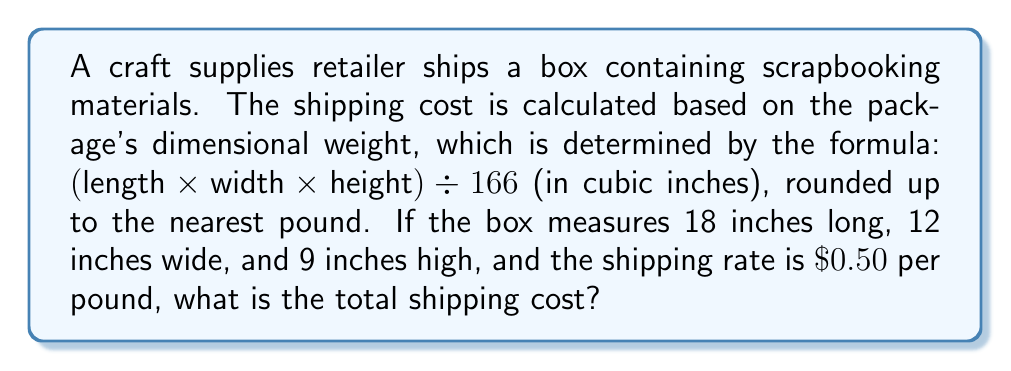Teach me how to tackle this problem. 1. Calculate the volume of the box:
   $\text{Volume} = \text{length} \times \text{width} \times \text{height}$
   $\text{Volume} = 18 \times 12 \times 9 = 1,944 \text{ cubic inches}$

2. Calculate the dimensional weight:
   $\text{Dimensional Weight} = \frac{\text{Volume}}{166}$
   $\text{Dimensional Weight} = \frac{1,944}{166} \approx 11.71 \text{ pounds}$

3. Round up the dimensional weight to the nearest pound:
   $\text{Rounded Weight} = 12 \text{ pounds}$

4. Calculate the shipping cost:
   $\text{Shipping Cost} = \text{Rounded Weight} \times \text{Rate per pound}$
   $\text{Shipping Cost} = 12 \times \$0.50 = \$6.00$

Therefore, the total shipping cost for the scrapbooking materials box is $\$6.00$.
Answer: $\$6.00$ 